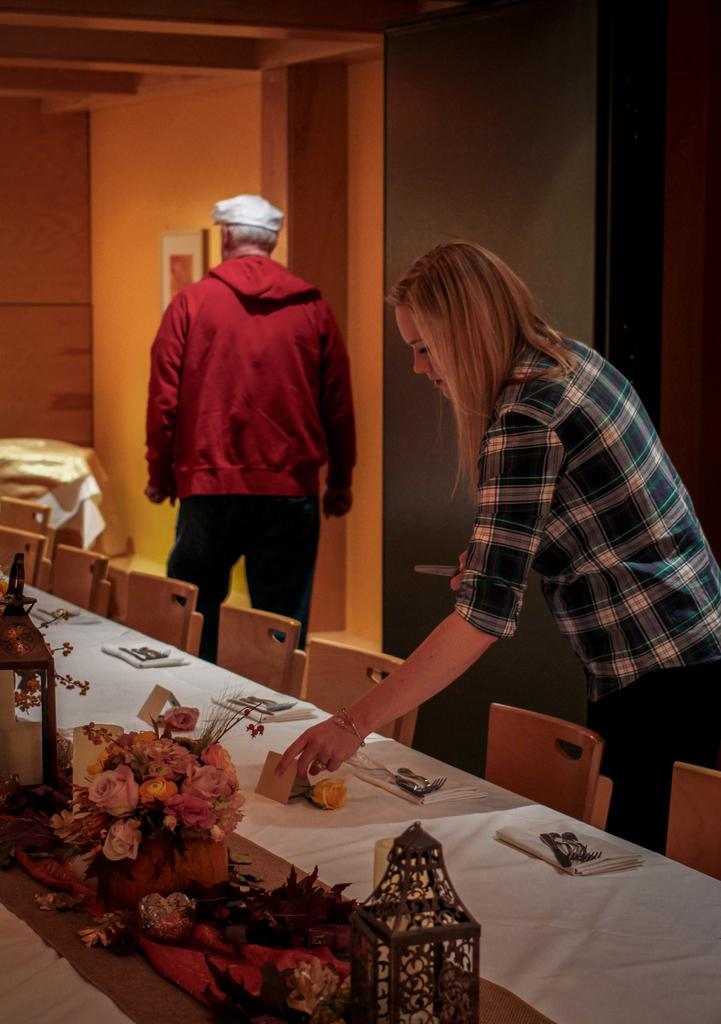Who is the main subject in the image? There is a woman in the image. What is the woman doing in the image? The woman is placing objects on a table. Is there anyone else in the image besides the woman? Yes, there is a man standing behind the woman. What type of knife is the woman using to balance on the skate in the image? There is no knife, balancing act, or skate present in the image. 